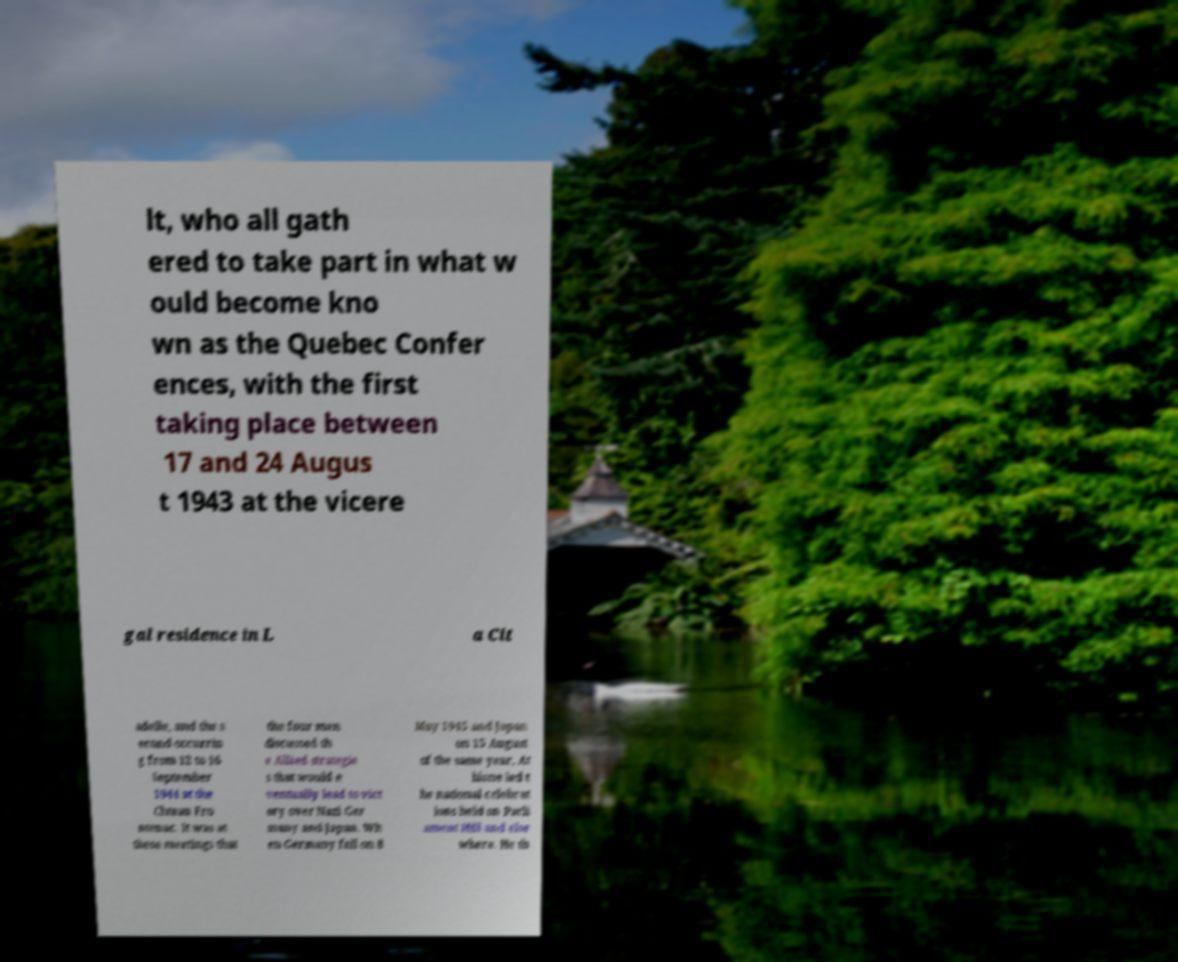I need the written content from this picture converted into text. Can you do that? lt, who all gath ered to take part in what w ould become kno wn as the Quebec Confer ences, with the first taking place between 17 and 24 Augus t 1943 at the vicere gal residence in L a Cit adelle, and the s econd occurrin g from 12 to 16 September 1944 at the Chteau Fro ntenac. It was at these meetings that the four men discussed th e Allied strategie s that would e ventually lead to vict ory over Nazi Ger many and Japan. Wh en Germany fell on 8 May 1945 and Japan on 15 August of the same year, At hlone led t he national celebrat ions held on Parli ament Hill and else where. He th 